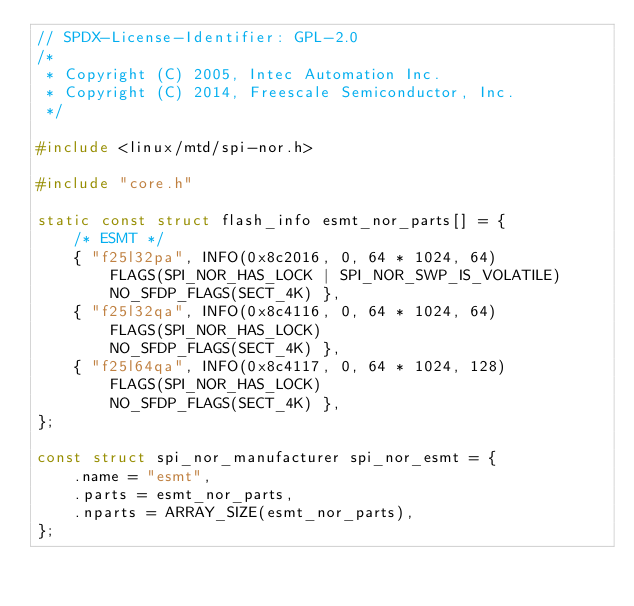Convert code to text. <code><loc_0><loc_0><loc_500><loc_500><_C_>// SPDX-License-Identifier: GPL-2.0
/*
 * Copyright (C) 2005, Intec Automation Inc.
 * Copyright (C) 2014, Freescale Semiconductor, Inc.
 */

#include <linux/mtd/spi-nor.h>

#include "core.h"

static const struct flash_info esmt_nor_parts[] = {
	/* ESMT */
	{ "f25l32pa", INFO(0x8c2016, 0, 64 * 1024, 64)
		FLAGS(SPI_NOR_HAS_LOCK | SPI_NOR_SWP_IS_VOLATILE)
		NO_SFDP_FLAGS(SECT_4K) },
	{ "f25l32qa", INFO(0x8c4116, 0, 64 * 1024, 64)
		FLAGS(SPI_NOR_HAS_LOCK)
		NO_SFDP_FLAGS(SECT_4K) },
	{ "f25l64qa", INFO(0x8c4117, 0, 64 * 1024, 128)
		FLAGS(SPI_NOR_HAS_LOCK)
		NO_SFDP_FLAGS(SECT_4K) },
};

const struct spi_nor_manufacturer spi_nor_esmt = {
	.name = "esmt",
	.parts = esmt_nor_parts,
	.nparts = ARRAY_SIZE(esmt_nor_parts),
};
</code> 